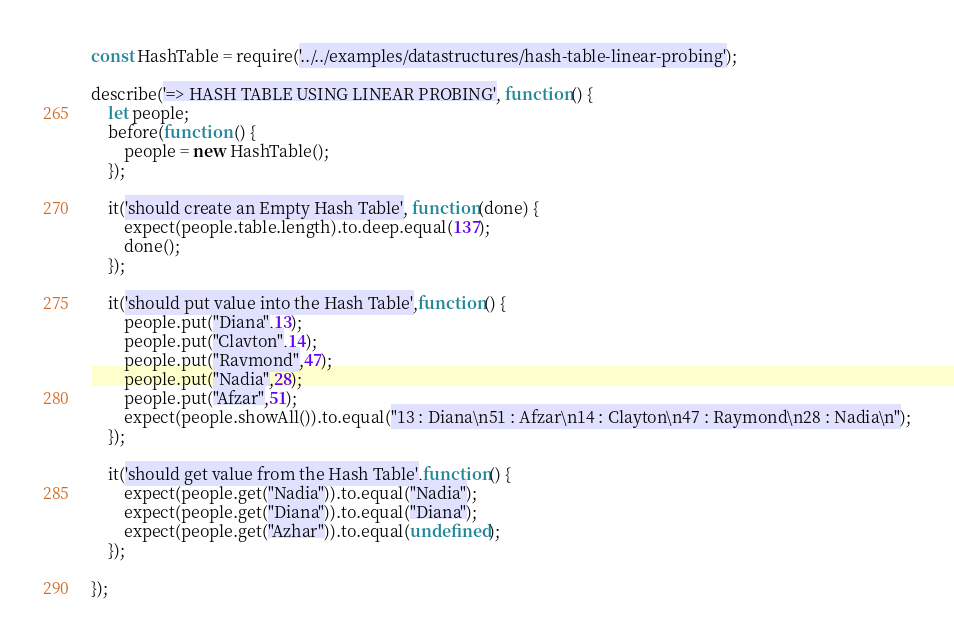<code> <loc_0><loc_0><loc_500><loc_500><_JavaScript_>const HashTable = require('../../examples/datastructures/hash-table-linear-probing');

describe('=> HASH TABLE USING LINEAR PROBING', function() {
	let people;
	before(function () {
		people = new HashTable();
	});

	it('should create an Empty Hash Table', function(done) {
		expect(people.table.length).to.deep.equal(137);
		done();
	});

	it('should put value into the Hash Table',function() {
		people.put("Diana",13);
		people.put("Clayton",14);
		people.put("Raymond",47);
		people.put("Nadia",28);
		people.put("Afzar",51);
		expect(people.showAll()).to.equal("13 : Diana\n51 : Afzar\n14 : Clayton\n47 : Raymond\n28 : Nadia\n");
	});

	it('should get value from the Hash Table',function() {
		expect(people.get("Nadia")).to.equal("Nadia");
		expect(people.get("Diana")).to.equal("Diana");
		expect(people.get("Azhar")).to.equal(undefined);
	});

});
</code> 